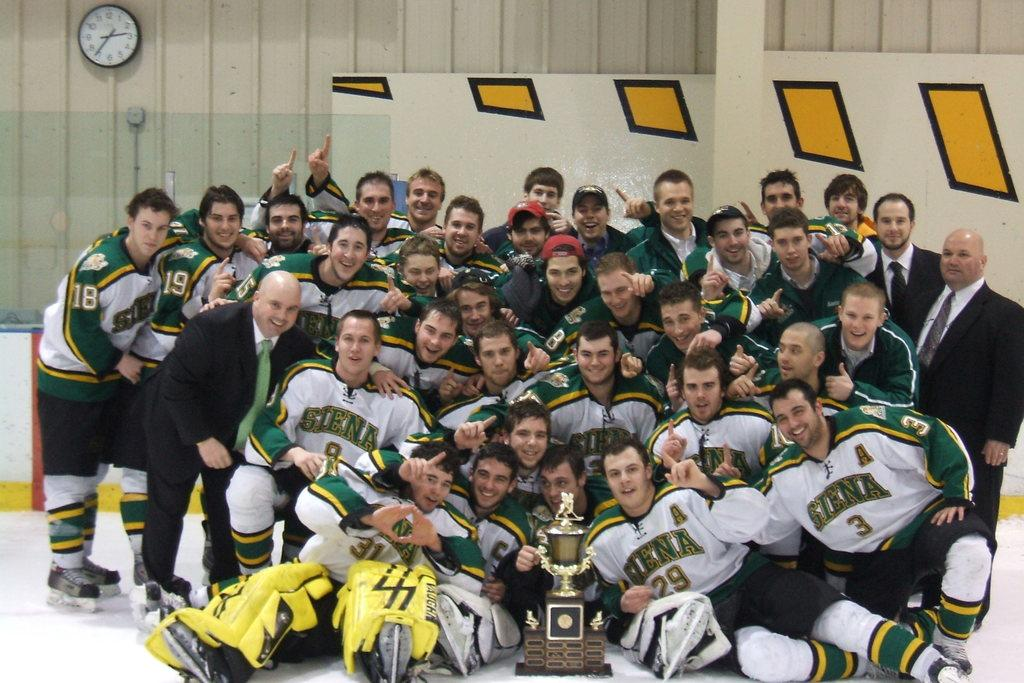What are the people in the image doing? There is a group of people on the ground in the image. What object can be seen in the image that might be associated with a competition or achievement? There is a trophy in the image. What can be seen in the background of the image? There is a clock and a wall in the background of the image. What type of crayon is being used by the people in the image? There are no crayons present in the image; the people are not engaged in any activity that would involve crayons. 